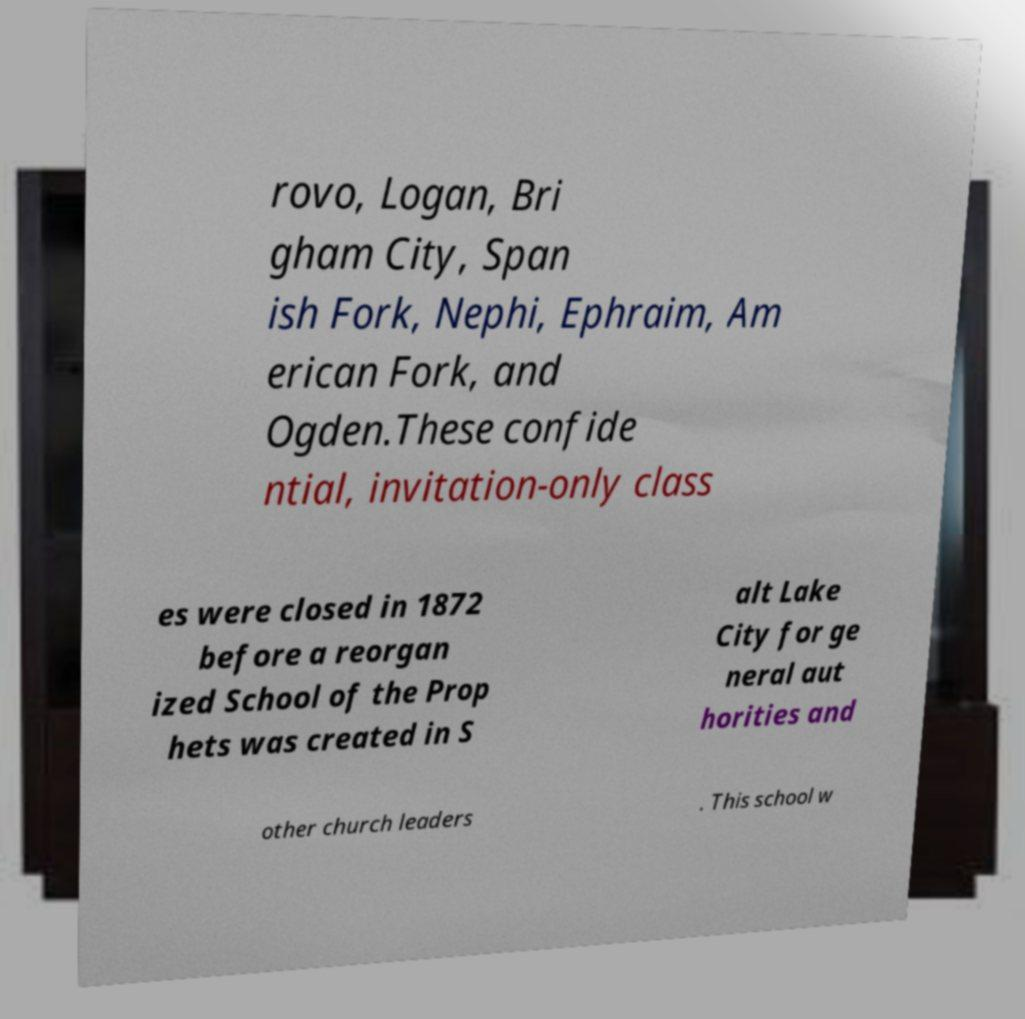I need the written content from this picture converted into text. Can you do that? rovo, Logan, Bri gham City, Span ish Fork, Nephi, Ephraim, Am erican Fork, and Ogden.These confide ntial, invitation-only class es were closed in 1872 before a reorgan ized School of the Prop hets was created in S alt Lake City for ge neral aut horities and other church leaders . This school w 